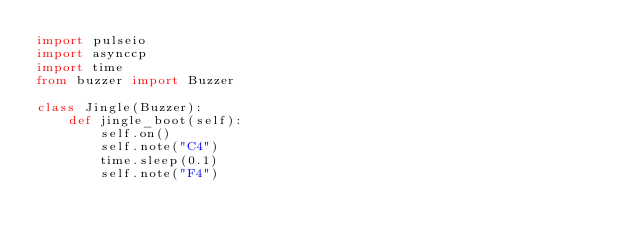Convert code to text. <code><loc_0><loc_0><loc_500><loc_500><_Python_>import pulseio
import asynccp
import time
from buzzer import Buzzer

class Jingle(Buzzer):
    def jingle_boot(self):
        self.on()
        self.note("C4")
        time.sleep(0.1)
        self.note("F4")</code> 